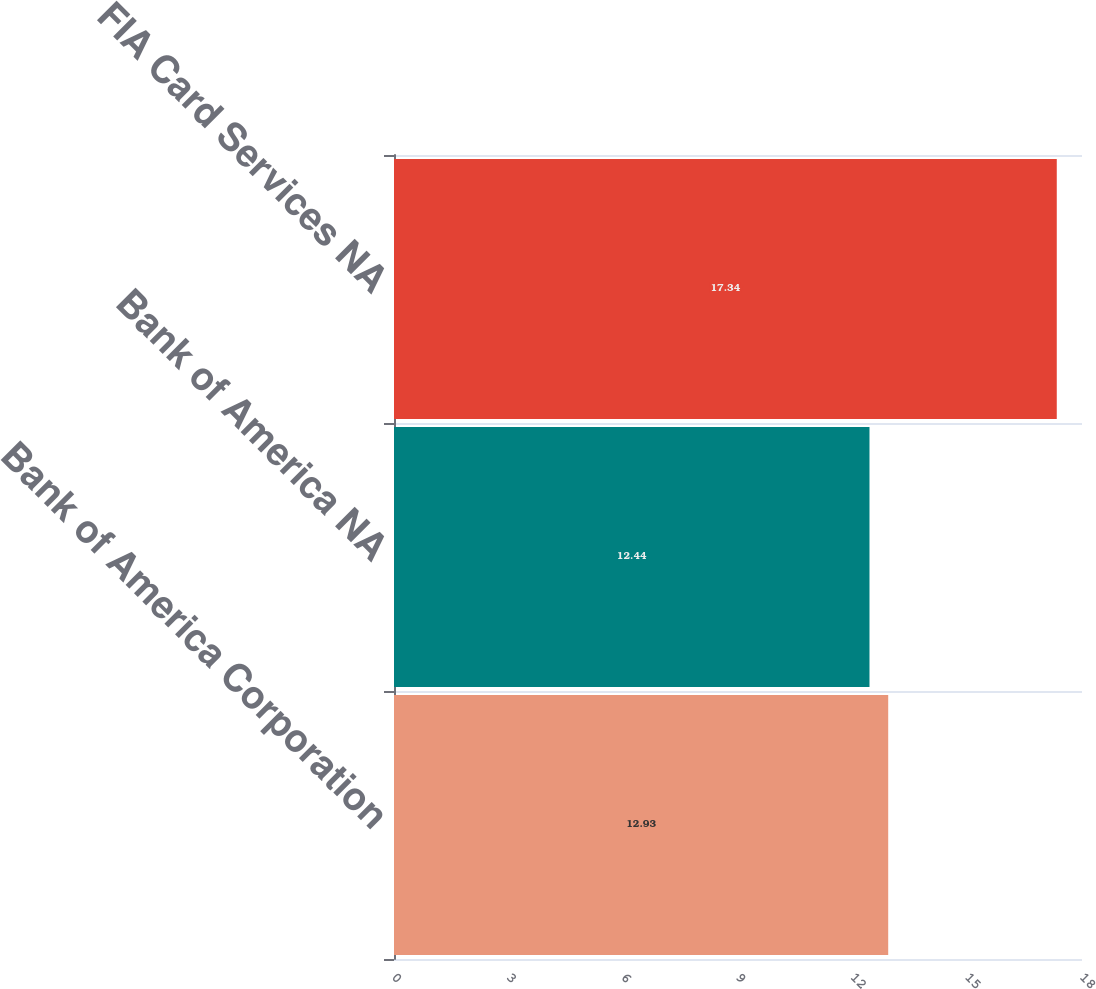Convert chart. <chart><loc_0><loc_0><loc_500><loc_500><bar_chart><fcel>Bank of America Corporation<fcel>Bank of America NA<fcel>FIA Card Services NA<nl><fcel>12.93<fcel>12.44<fcel>17.34<nl></chart> 